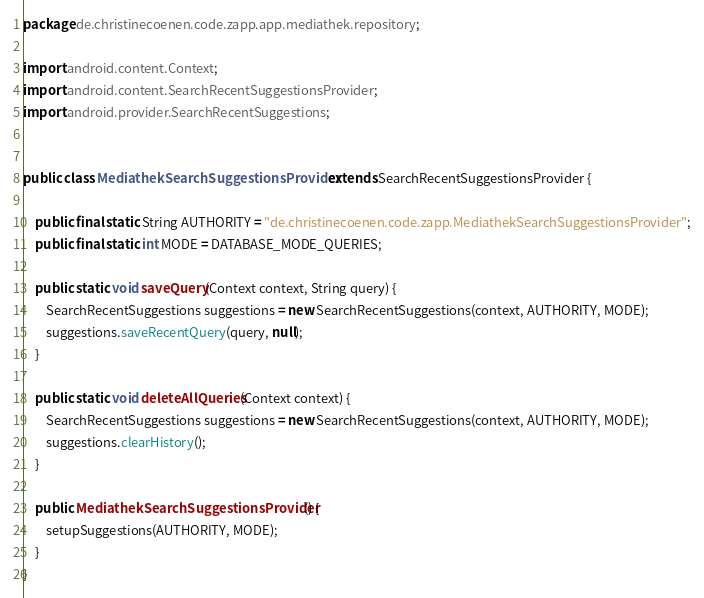<code> <loc_0><loc_0><loc_500><loc_500><_Java_>package de.christinecoenen.code.zapp.app.mediathek.repository;

import android.content.Context;
import android.content.SearchRecentSuggestionsProvider;
import android.provider.SearchRecentSuggestions;


public class MediathekSearchSuggestionsProvider extends SearchRecentSuggestionsProvider {

	public final static String AUTHORITY = "de.christinecoenen.code.zapp.MediathekSearchSuggestionsProvider";
	public final static int MODE = DATABASE_MODE_QUERIES;

	public static void saveQuery(Context context, String query) {
		SearchRecentSuggestions suggestions = new SearchRecentSuggestions(context, AUTHORITY, MODE);
		suggestions.saveRecentQuery(query, null);
	}

	public static void deleteAllQueries(Context context) {
		SearchRecentSuggestions suggestions = new SearchRecentSuggestions(context, AUTHORITY, MODE);
		suggestions.clearHistory();
	}

	public MediathekSearchSuggestionsProvider() {
		setupSuggestions(AUTHORITY, MODE);
	}
}
</code> 